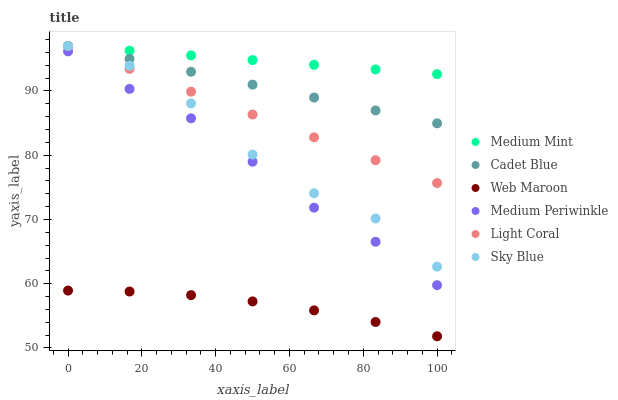Does Web Maroon have the minimum area under the curve?
Answer yes or no. Yes. Does Medium Mint have the maximum area under the curve?
Answer yes or no. Yes. Does Cadet Blue have the minimum area under the curve?
Answer yes or no. No. Does Cadet Blue have the maximum area under the curve?
Answer yes or no. No. Is Medium Mint the smoothest?
Answer yes or no. Yes. Is Sky Blue the roughest?
Answer yes or no. Yes. Is Cadet Blue the smoothest?
Answer yes or no. No. Is Cadet Blue the roughest?
Answer yes or no. No. Does Web Maroon have the lowest value?
Answer yes or no. Yes. Does Cadet Blue have the lowest value?
Answer yes or no. No. Does Sky Blue have the highest value?
Answer yes or no. Yes. Does Web Maroon have the highest value?
Answer yes or no. No. Is Web Maroon less than Sky Blue?
Answer yes or no. Yes. Is Cadet Blue greater than Medium Periwinkle?
Answer yes or no. Yes. Does Light Coral intersect Sky Blue?
Answer yes or no. Yes. Is Light Coral less than Sky Blue?
Answer yes or no. No. Is Light Coral greater than Sky Blue?
Answer yes or no. No. Does Web Maroon intersect Sky Blue?
Answer yes or no. No. 